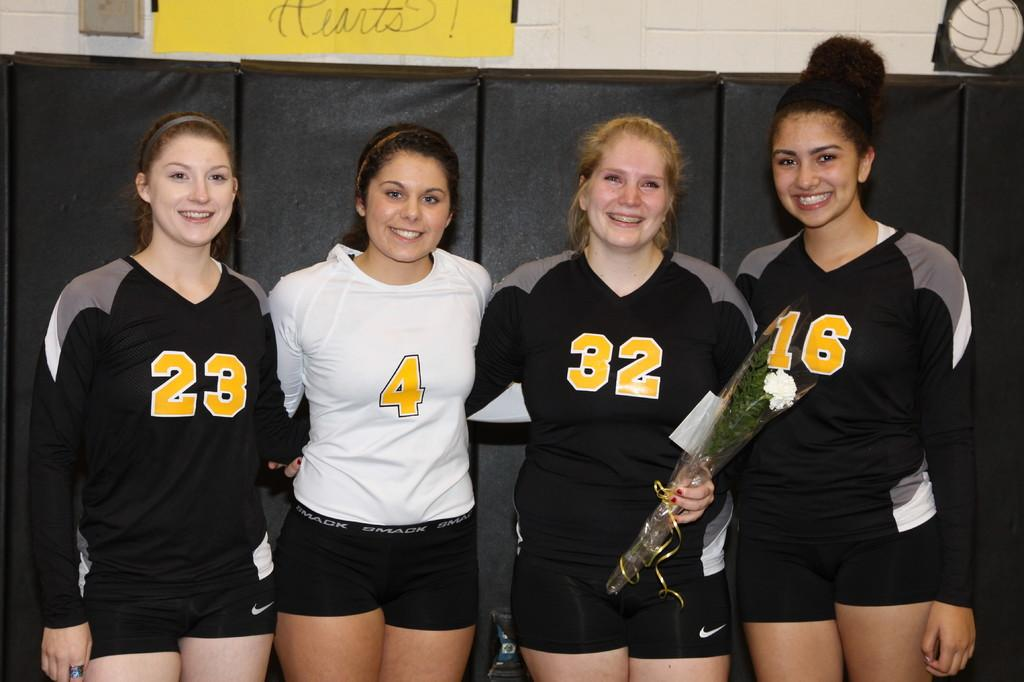Provide a one-sentence caption for the provided image. A group of 4 girls three in black shirts and one in a white shirt with the number 4 on it. 